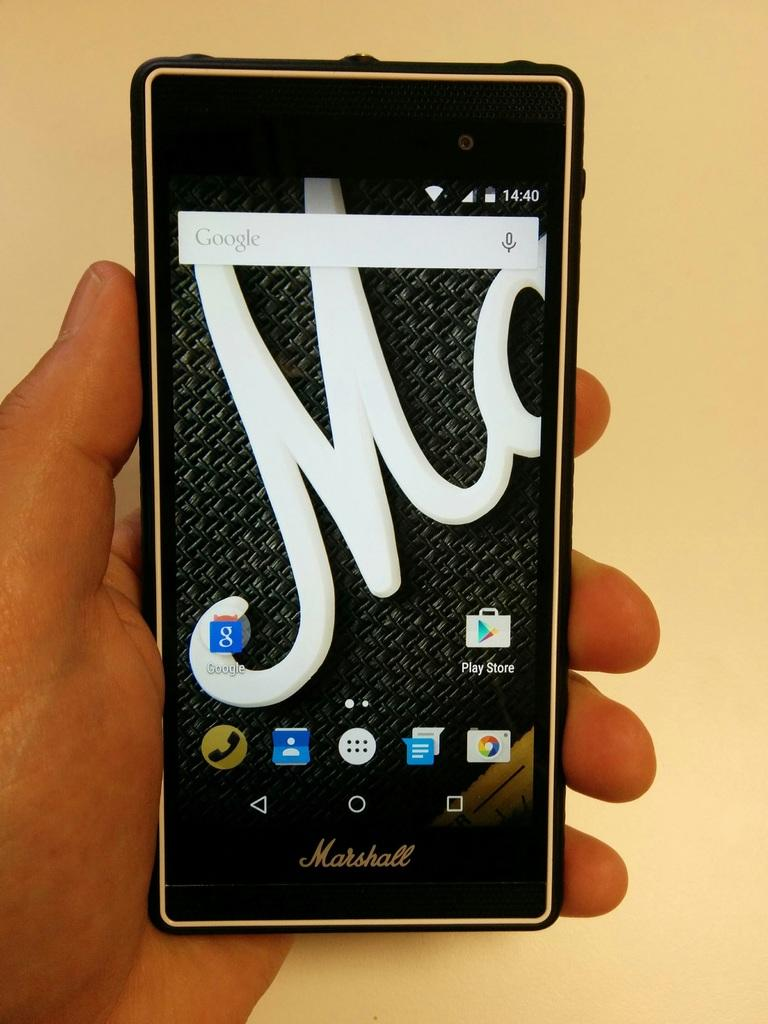<image>
Describe the image concisely. A hand is holding up a cell phone made by Marshall. 